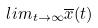<formula> <loc_0><loc_0><loc_500><loc_500>l i m _ { t \rightarrow \infty } \overline { x } ( t )</formula> 